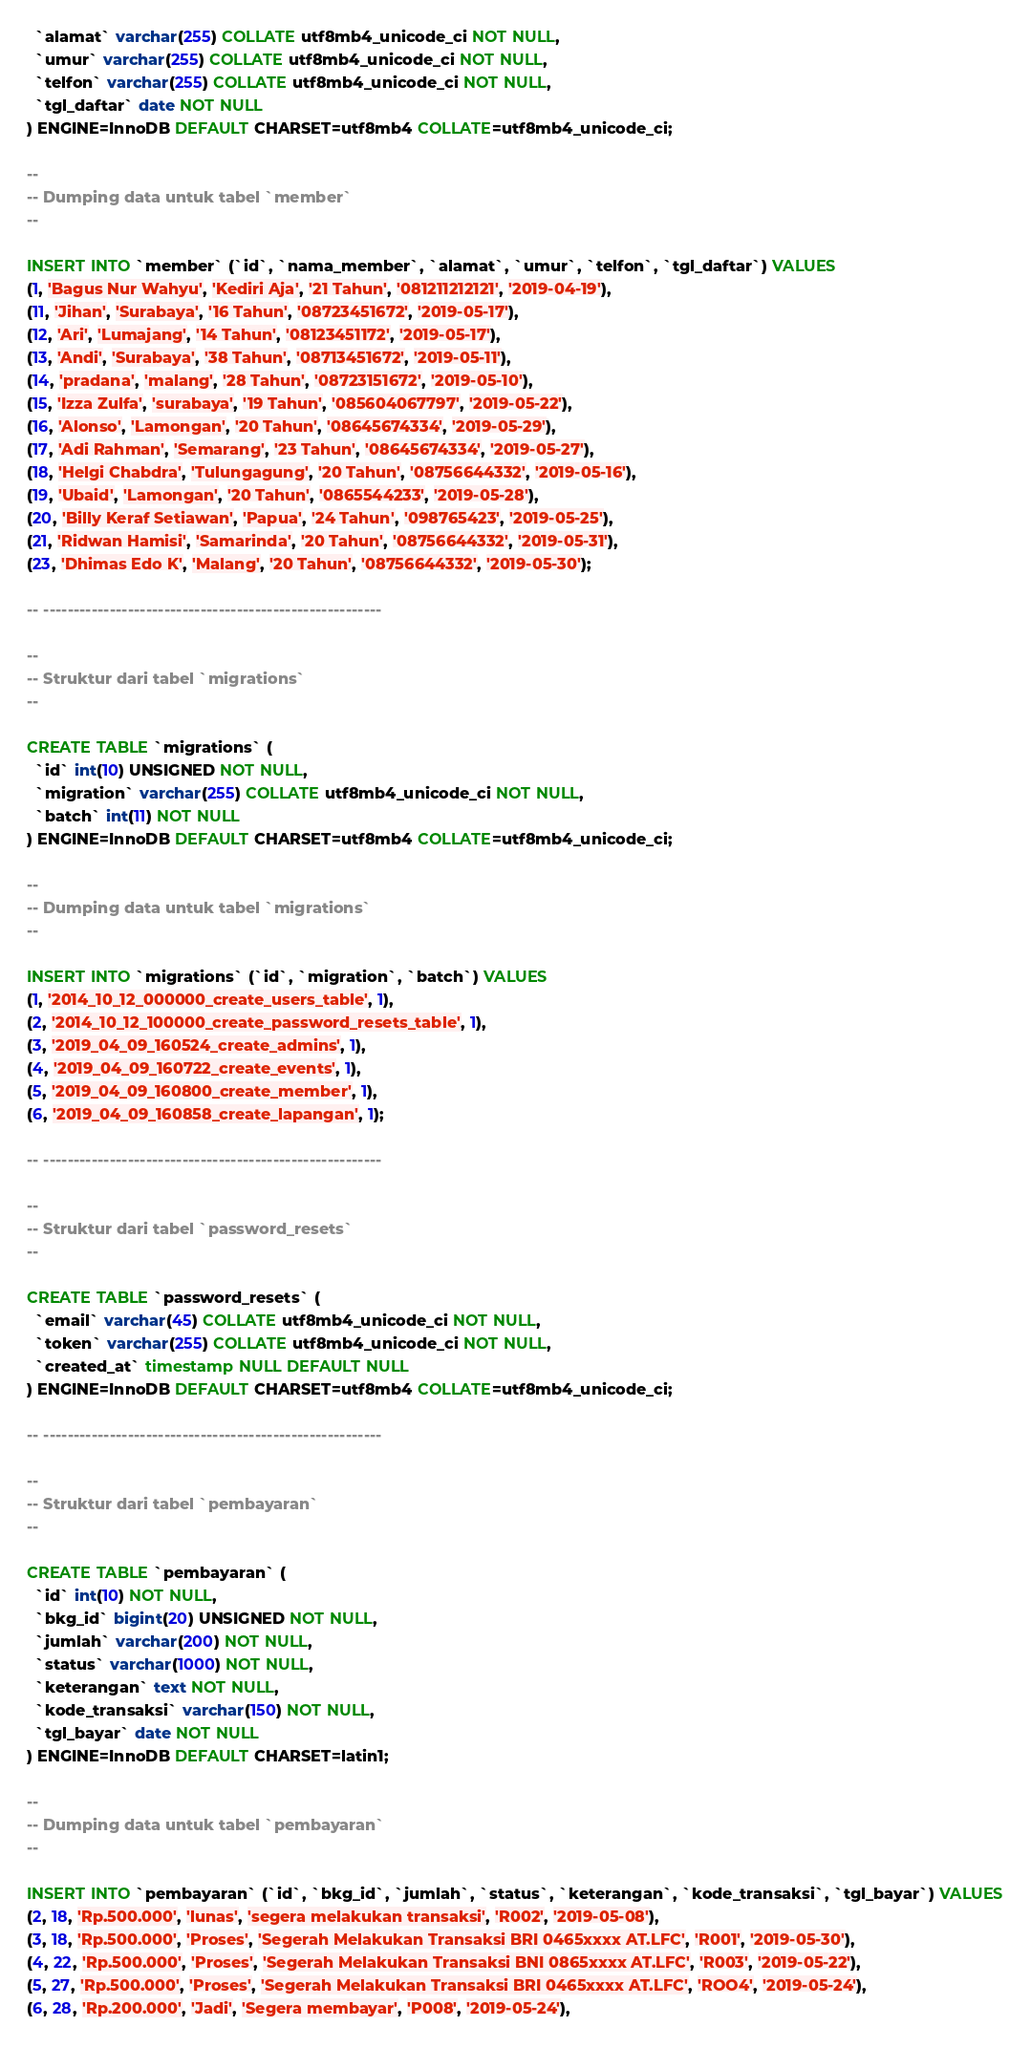<code> <loc_0><loc_0><loc_500><loc_500><_SQL_>  `alamat` varchar(255) COLLATE utf8mb4_unicode_ci NOT NULL,
  `umur` varchar(255) COLLATE utf8mb4_unicode_ci NOT NULL,
  `telfon` varchar(255) COLLATE utf8mb4_unicode_ci NOT NULL,
  `tgl_daftar` date NOT NULL
) ENGINE=InnoDB DEFAULT CHARSET=utf8mb4 COLLATE=utf8mb4_unicode_ci;

--
-- Dumping data untuk tabel `member`
--

INSERT INTO `member` (`id`, `nama_member`, `alamat`, `umur`, `telfon`, `tgl_daftar`) VALUES
(1, 'Bagus Nur Wahyu', 'Kediri Aja', '21 Tahun', '081211212121', '2019-04-19'),
(11, 'Jihan', 'Surabaya', '16 Tahun', '08723451672', '2019-05-17'),
(12, 'Ari', 'Lumajang', '14 Tahun', '08123451172', '2019-05-17'),
(13, 'Andi', 'Surabaya', '38 Tahun', '08713451672', '2019-05-11'),
(14, 'pradana', 'malang', '28 Tahun', '08723151672', '2019-05-10'),
(15, 'Izza Zulfa', 'surabaya', '19 Tahun', '085604067797', '2019-05-22'),
(16, 'Alonso', 'Lamongan', '20 Tahun', '08645674334', '2019-05-29'),
(17, 'Adi Rahman', 'Semarang', '23 Tahun', '08645674334', '2019-05-27'),
(18, 'Helgi Chabdra', 'Tulungagung', '20 Tahun', '08756644332', '2019-05-16'),
(19, 'Ubaid', 'Lamongan', '20 Tahun', '0865544233', '2019-05-28'),
(20, 'Billy Keraf Setiawan', 'Papua', '24 Tahun', '098765423', '2019-05-25'),
(21, 'Ridwan Hamisi', 'Samarinda', '20 Tahun', '08756644332', '2019-05-31'),
(23, 'Dhimas Edo K', 'Malang', '20 Tahun', '08756644332', '2019-05-30');

-- --------------------------------------------------------

--
-- Struktur dari tabel `migrations`
--

CREATE TABLE `migrations` (
  `id` int(10) UNSIGNED NOT NULL,
  `migration` varchar(255) COLLATE utf8mb4_unicode_ci NOT NULL,
  `batch` int(11) NOT NULL
) ENGINE=InnoDB DEFAULT CHARSET=utf8mb4 COLLATE=utf8mb4_unicode_ci;

--
-- Dumping data untuk tabel `migrations`
--

INSERT INTO `migrations` (`id`, `migration`, `batch`) VALUES
(1, '2014_10_12_000000_create_users_table', 1),
(2, '2014_10_12_100000_create_password_resets_table', 1),
(3, '2019_04_09_160524_create_admins', 1),
(4, '2019_04_09_160722_create_events', 1),
(5, '2019_04_09_160800_create_member', 1),
(6, '2019_04_09_160858_create_lapangan', 1);

-- --------------------------------------------------------

--
-- Struktur dari tabel `password_resets`
--

CREATE TABLE `password_resets` (
  `email` varchar(45) COLLATE utf8mb4_unicode_ci NOT NULL,
  `token` varchar(255) COLLATE utf8mb4_unicode_ci NOT NULL,
  `created_at` timestamp NULL DEFAULT NULL
) ENGINE=InnoDB DEFAULT CHARSET=utf8mb4 COLLATE=utf8mb4_unicode_ci;

-- --------------------------------------------------------

--
-- Struktur dari tabel `pembayaran`
--

CREATE TABLE `pembayaran` (
  `id` int(10) NOT NULL,
  `bkg_id` bigint(20) UNSIGNED NOT NULL,
  `jumlah` varchar(200) NOT NULL,
  `status` varchar(1000) NOT NULL,
  `keterangan` text NOT NULL,
  `kode_transaksi` varchar(150) NOT NULL,
  `tgl_bayar` date NOT NULL
) ENGINE=InnoDB DEFAULT CHARSET=latin1;

--
-- Dumping data untuk tabel `pembayaran`
--

INSERT INTO `pembayaran` (`id`, `bkg_id`, `jumlah`, `status`, `keterangan`, `kode_transaksi`, `tgl_bayar`) VALUES
(2, 18, 'Rp.500.000', 'lunas', 'segera melakukan transaksi', 'R002', '2019-05-08'),
(3, 18, 'Rp.500.000', 'Proses', 'Segerah Melakukan Transaksi BRI 0465xxxx AT.LFC', 'R001', '2019-05-30'),
(4, 22, 'Rp.500.000', 'Proses', 'Segerah Melakukan Transaksi BNI 0865xxxx AT.LFC', 'R003', '2019-05-22'),
(5, 27, 'Rp.500.000', 'Proses', 'Segerah Melakukan Transaksi BRI 0465xxxx AT.LFC', 'ROO4', '2019-05-24'),
(6, 28, 'Rp.200.000', 'Jadi', 'Segera membayar', 'P008', '2019-05-24'),</code> 